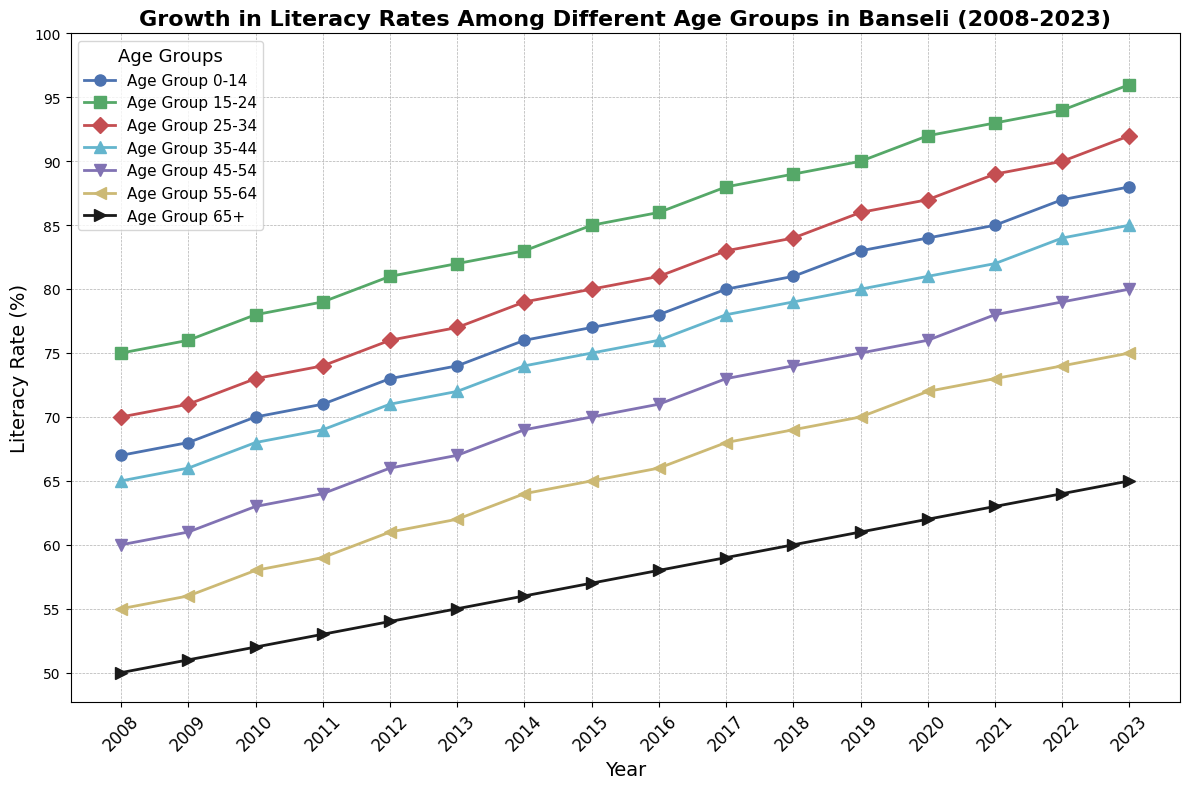What trend do you observe in the literacy rate of the 65+ age group over the past 15 years? From the plot, observe that the literacy rate for the 65+ age group started at 50% in 2008 and increased steadily each year, reaching 65% by 2023. This consistent rise shows a positive trend in literacy rate for this age group.
Answer: A consistent increase Which age group had the highest literacy rate in 2023? In the 2023 data, the age group 15-24 had the highest literacy rate, marked by the peak point at the topmost position in the plot, reaching 96%.
Answer: 15-24 age group Compare the literacy rate of the age group 0-14 and 45-54 in 2010. Which group had a higher rate and by how much? In 2010, the literacy rate for the 0-14 age group was 70%, while for the 45-54 age group, it was 63%. Subtracting these rates, we find that the 0-14 age group had a 7% higher literacy rate.
Answer: 0-14 by 7% Between which consecutive years did the age group 25-34 see the biggest increase in literacy rate? Analyzing the plot carefully, observe the steepest rise in the line corresponding to the 25-34 age group. The largest increase occurred between 2009 and 2010, where the rate increased from 71% to 73%, a 2% rise.
Answer: 2009 to 2010 What is the average literacy rate of the 55-64 age group over the entire period? Adding the yearly literacy rates from 2008 to 2023 for the 55-64 age group: (55 + 56 + 58 + 59 + 61 + 62 + 64 + 65 + 66 + 68 + 69 + 70 + 72 + 73 + 74) gives 1002. Dividing by 15 years, the average is 1002/15 = 66.8%.
Answer: 66.8% Which age group's literacy rate remained consistently higher than 70% throughout all the years? Referring to the plot, the age group 15-24 maintained literacy rates above 70% for the entire period from 2008 to 2023.
Answer: 15-24 age group How did the literacy rate of the 35-44 age group change from 2015 to 2020? From the plot, the 35-44 age group had a rate of 75% in 2015 and increased to 81% by 2020. This indicates a 6% rise over the five years.
Answer: Increased by 6% Which age group showed the least improvement, in terms of percentage increase, from 2008 to 2023? Comparing the percentage increase of each age group's literacy rate from 2008 to 2023, the 65+ age group had the smallest percentage increase, from 50% to 65%, a 15% rise over 15 years.
Answer: 65+ age group What was the literacy rate of the 0-14 age group in 2012 and 2013, and by how much did it increase between these years? From the plot, the literacy rate for the 0-14 age group was 73% in 2012 and 74% in 2013, indicating a 1% increase between these years.
Answer: Increased by 1% 